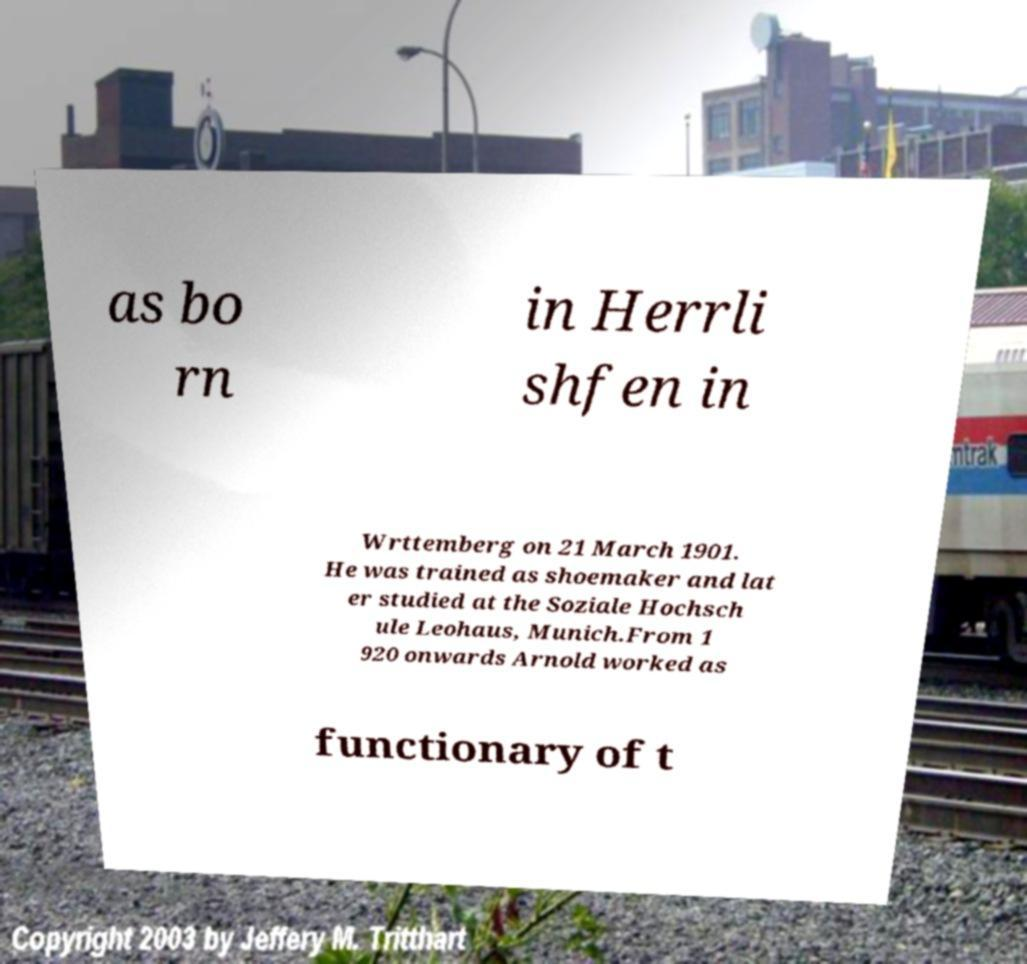For documentation purposes, I need the text within this image transcribed. Could you provide that? as bo rn in Herrli shfen in Wrttemberg on 21 March 1901. He was trained as shoemaker and lat er studied at the Soziale Hochsch ule Leohaus, Munich.From 1 920 onwards Arnold worked as functionary of t 